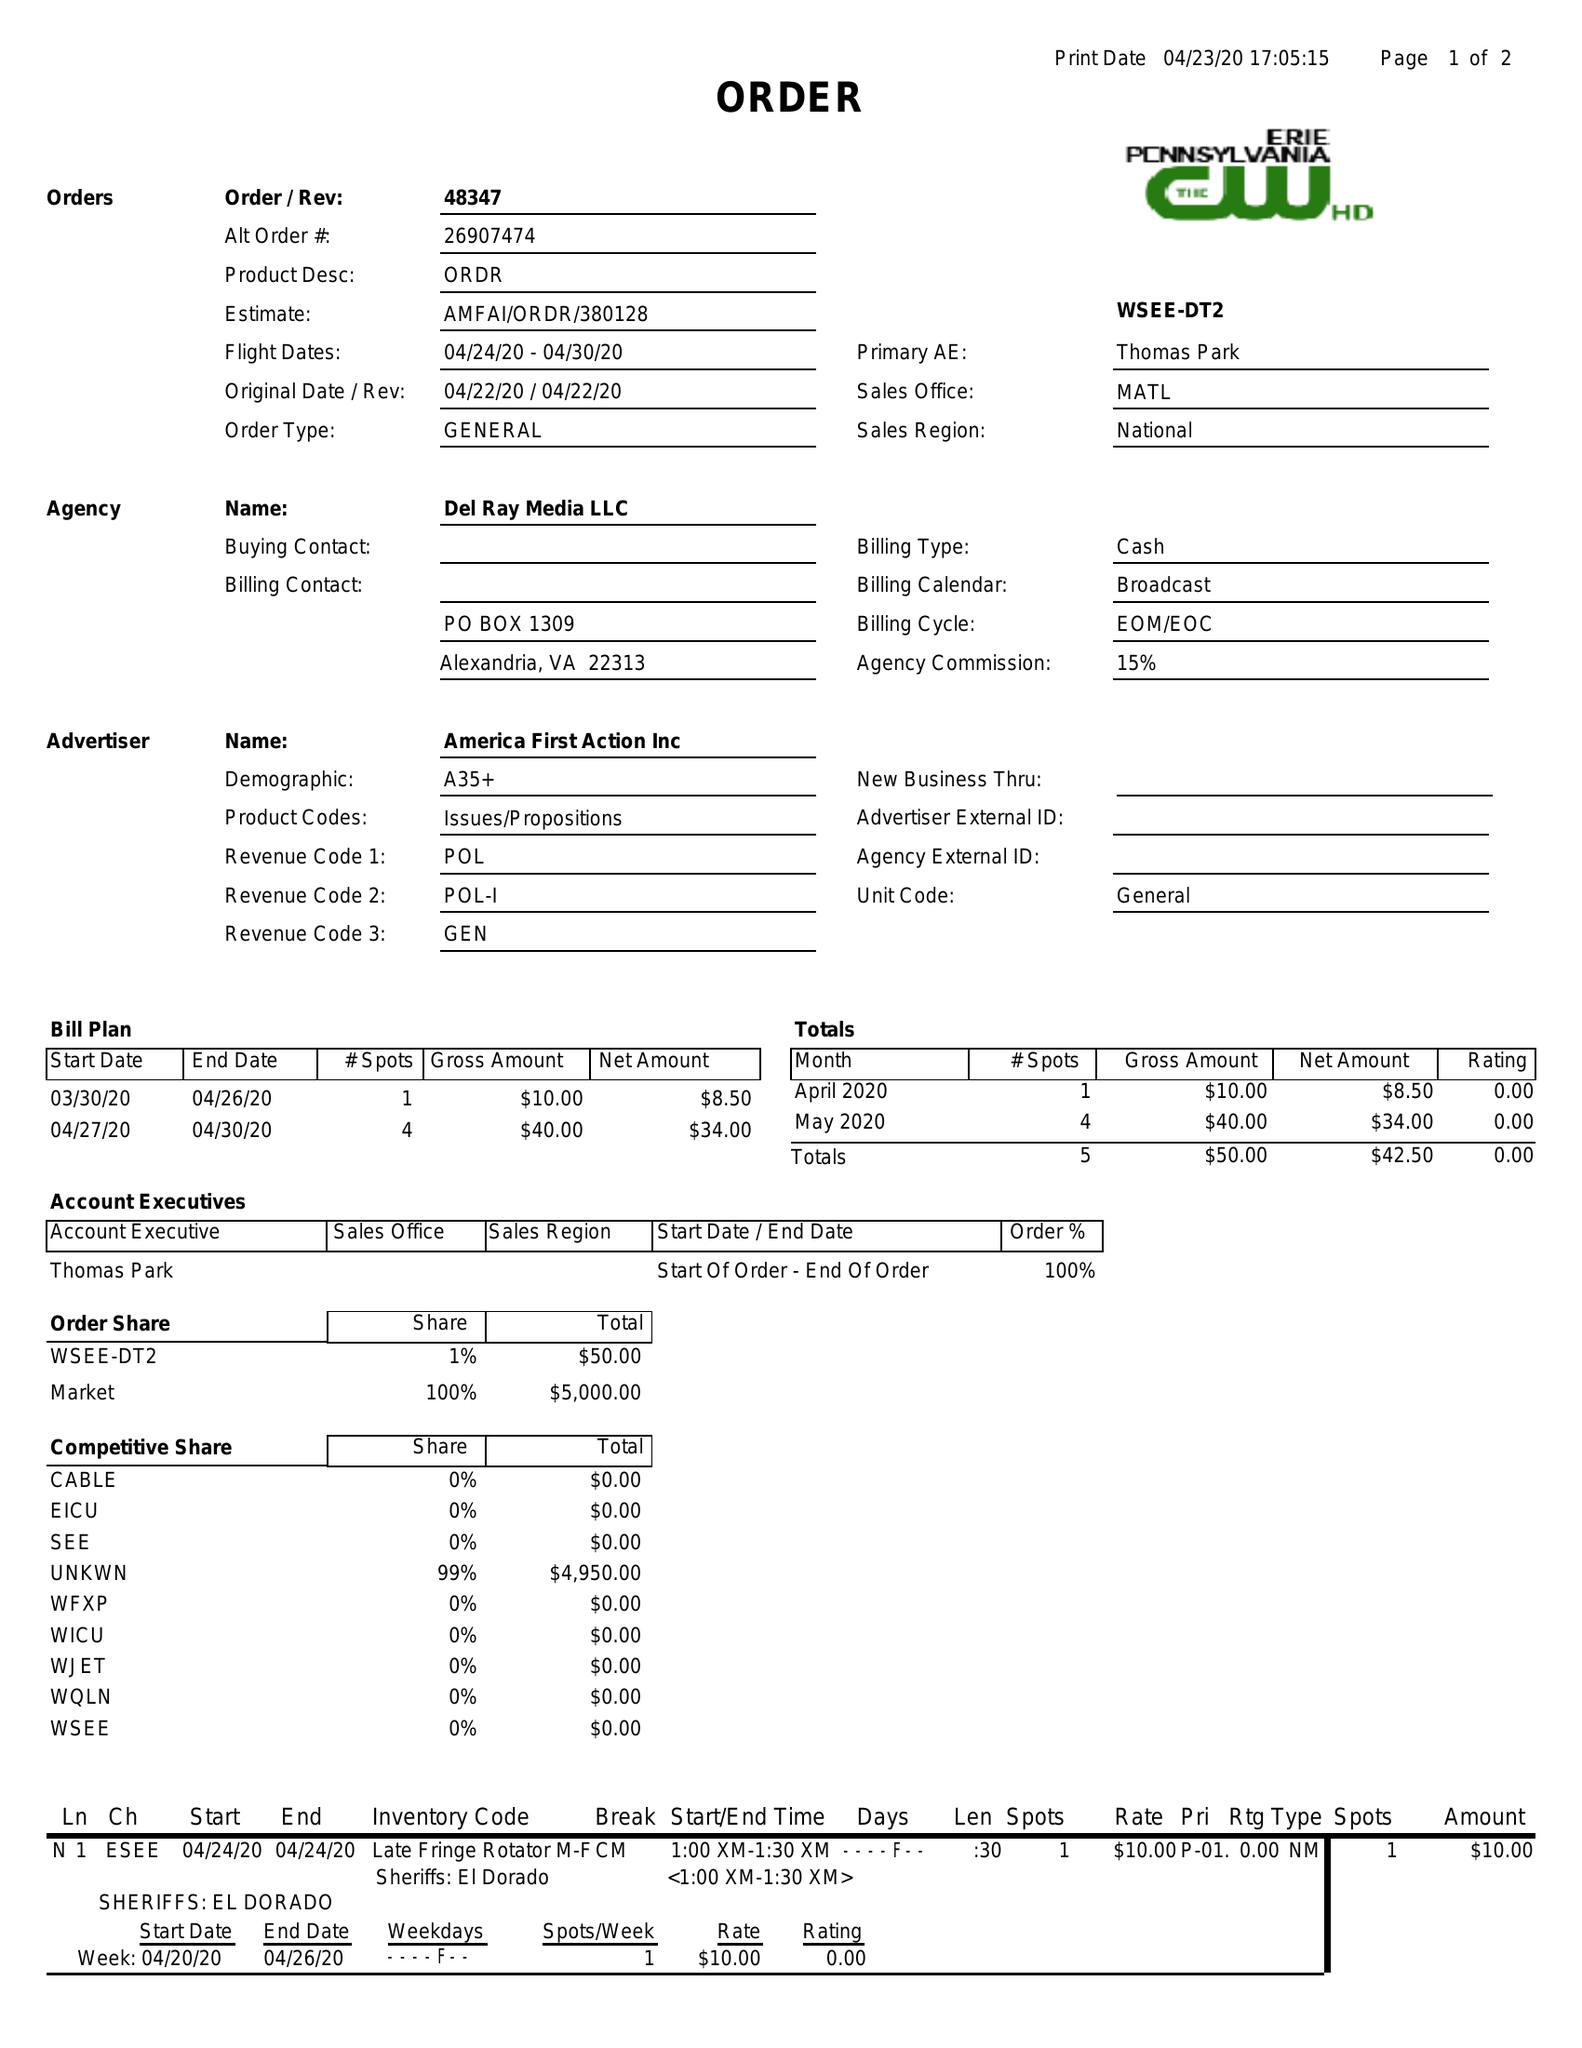What is the value for the flight_from?
Answer the question using a single word or phrase. 04/24/20 